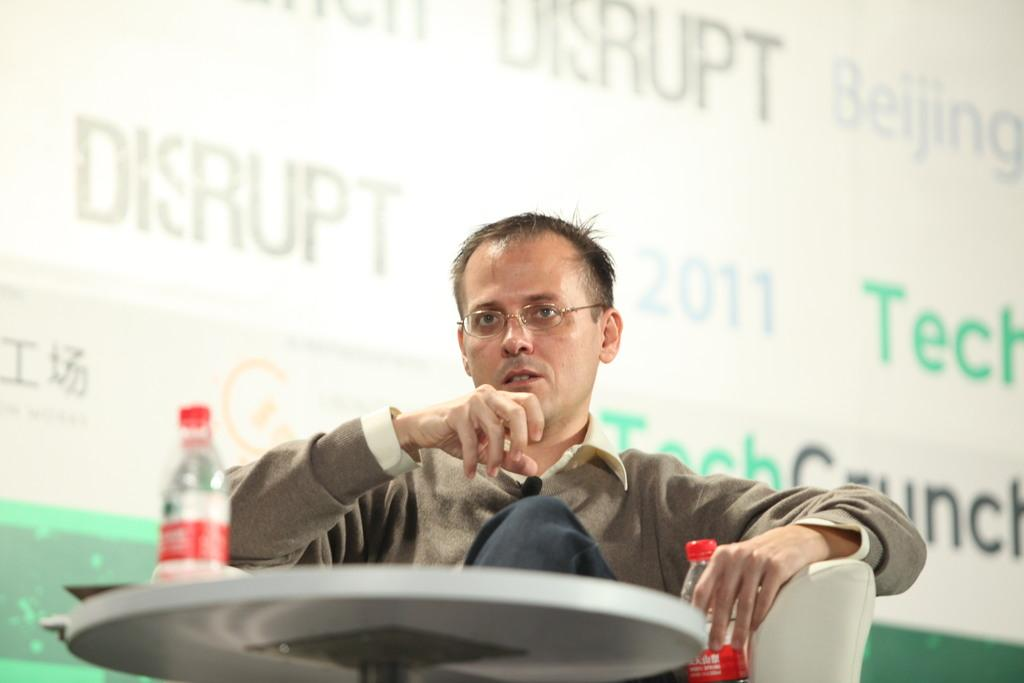What is the person in the image doing? The person is sitting on a chair. What object is the person holding in the image? The person is holding a water bottle. What piece of furniture is in front of the person? There is a table in front of the person. How many kitties are playing with stones on the table in the image? There are no kitties or stones present on the table in the image. 